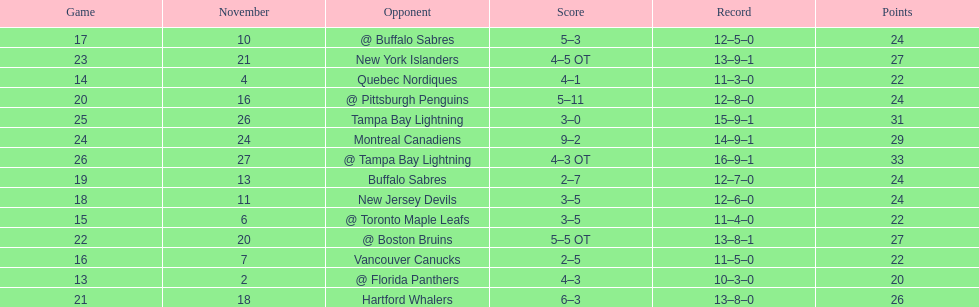Who had the most assists on the 1993-1994 flyers? Mark Recchi. 